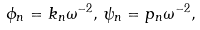<formula> <loc_0><loc_0><loc_500><loc_500>\phi _ { n } = k _ { n } \omega ^ { - 2 } , \, \psi _ { n } = p _ { n } \omega ^ { - 2 } ,</formula> 